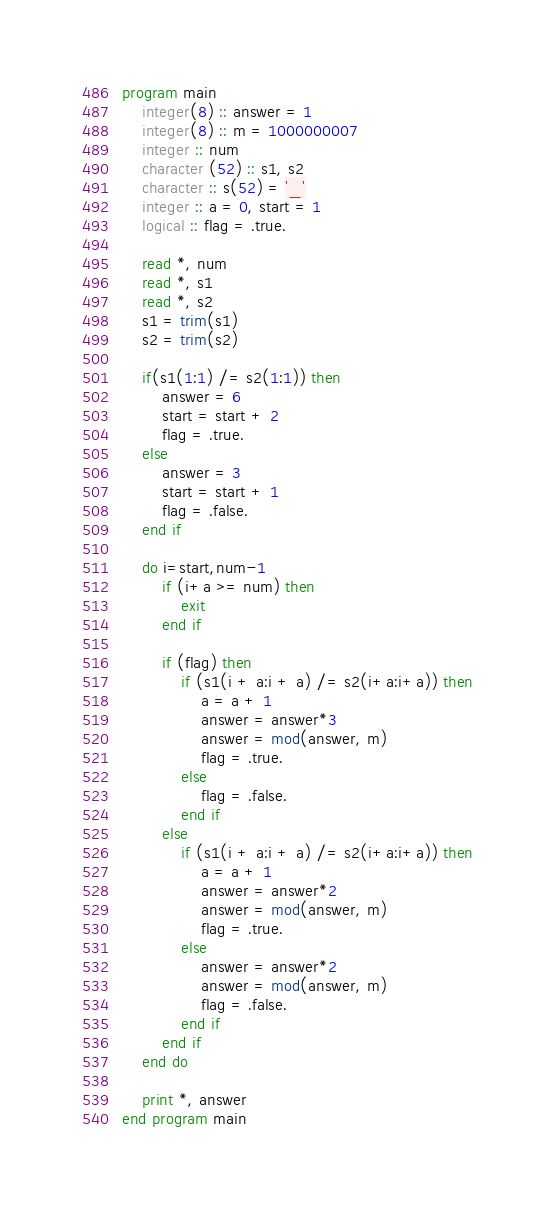Convert code to text. <code><loc_0><loc_0><loc_500><loc_500><_FORTRAN_>program main
    integer(8) :: answer = 1
    integer(8) :: m = 1000000007
    integer :: num
    character (52) :: s1, s2
    character :: s(52) = '_'
    integer :: a = 0, start = 1
    logical :: flag = .true.

    read *, num
    read *, s1
    read *, s2
    s1 = trim(s1)
    s2 = trim(s2)

    if(s1(1:1) /= s2(1:1)) then
        answer = 6
        start = start + 2
        flag = .true.
    else
        answer = 3
        start = start + 1
        flag = .false.
    end if

    do i=start,num-1
        if (i+a >= num) then
            exit
        end if

        if (flag) then
            if (s1(i + a:i + a) /= s2(i+a:i+a)) then
                a = a + 1
                answer = answer*3
                answer = mod(answer, m)
                flag = .true.
            else
                flag = .false.
            end if
        else
            if (s1(i + a:i + a) /= s2(i+a:i+a)) then
                a = a + 1
                answer = answer*2
                answer = mod(answer, m)
                flag = .true.
            else
                answer = answer*2
                answer = mod(answer, m)
                flag = .false.
            end if
        end if
    end do

    print *, answer
end program main</code> 